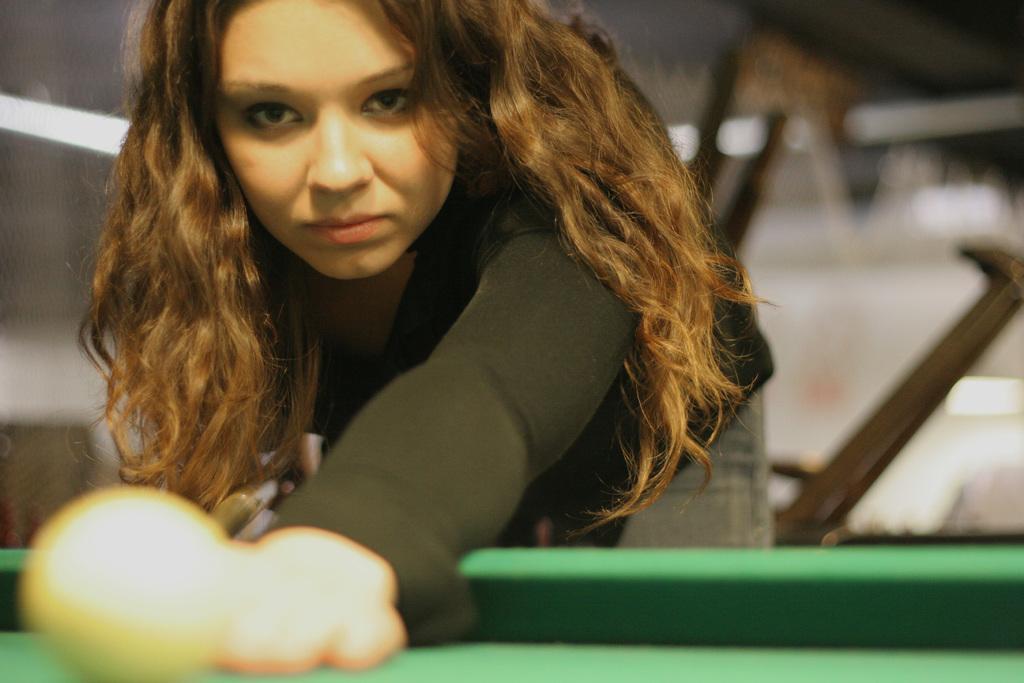Describe this image in one or two sentences. The women wearing black dress is playing snooker. 